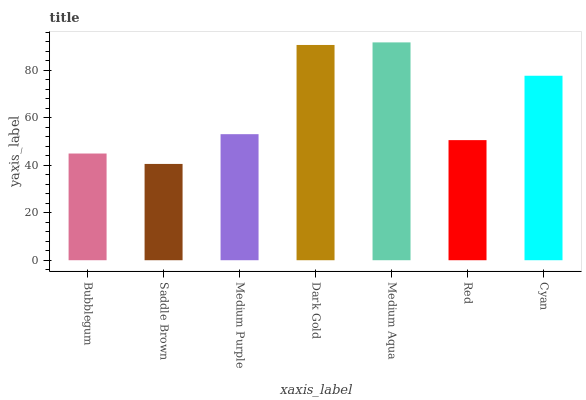Is Saddle Brown the minimum?
Answer yes or no. Yes. Is Medium Aqua the maximum?
Answer yes or no. Yes. Is Medium Purple the minimum?
Answer yes or no. No. Is Medium Purple the maximum?
Answer yes or no. No. Is Medium Purple greater than Saddle Brown?
Answer yes or no. Yes. Is Saddle Brown less than Medium Purple?
Answer yes or no. Yes. Is Saddle Brown greater than Medium Purple?
Answer yes or no. No. Is Medium Purple less than Saddle Brown?
Answer yes or no. No. Is Medium Purple the high median?
Answer yes or no. Yes. Is Medium Purple the low median?
Answer yes or no. Yes. Is Red the high median?
Answer yes or no. No. Is Cyan the low median?
Answer yes or no. No. 